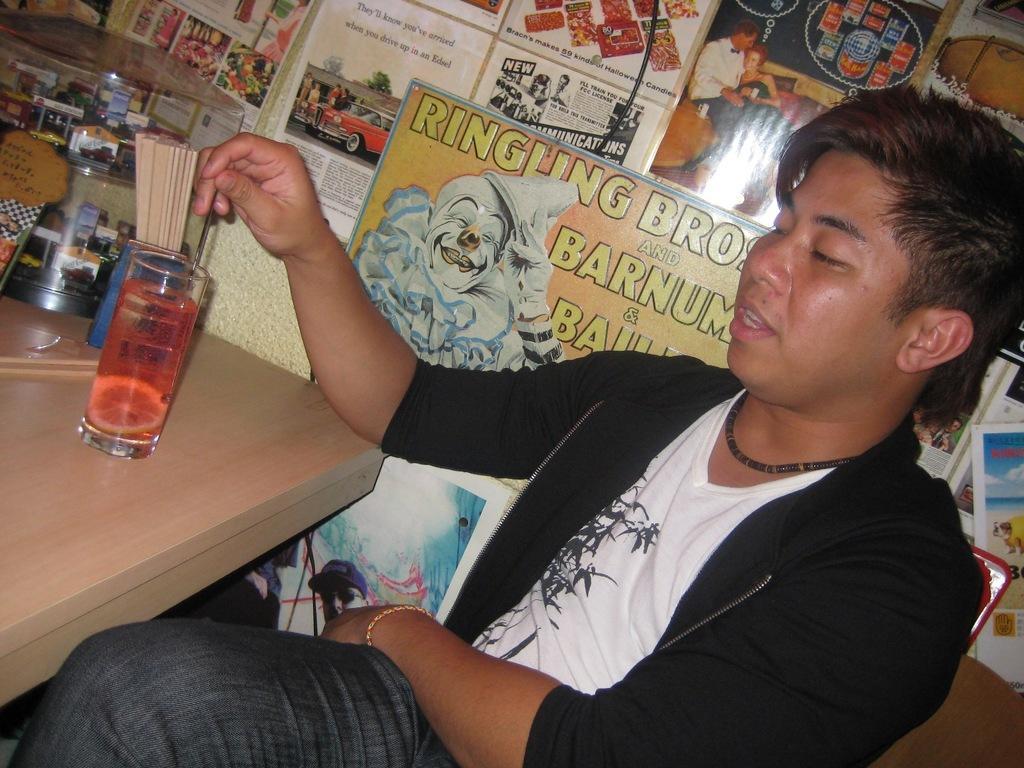Can you describe this image briefly? A man with black jacket and white t-shirt is sitting. In front of him there is a table with a glass, Bottle with sticks and a box on it. Behind him there are many poster to the wall stocked to it. 